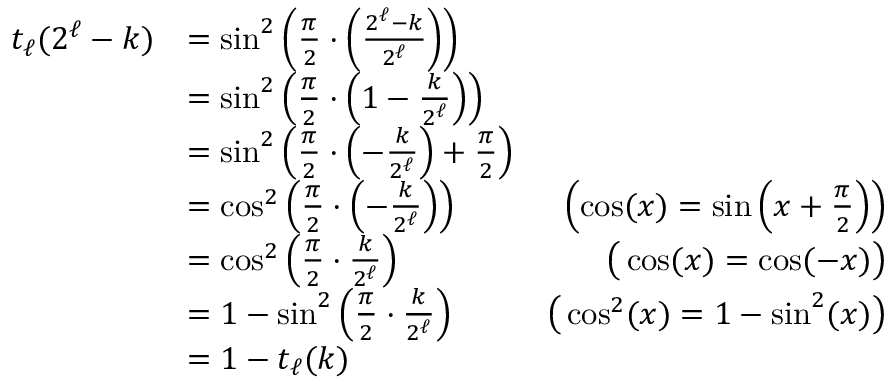<formula> <loc_0><loc_0><loc_500><loc_500>\begin{array} { r l r } { t _ { \ell } ( 2 ^ { \ell } - k ) } & { = \sin ^ { 2 } \left ( \frac { \pi } { 2 } \cdot \left ( \frac { 2 ^ { \ell } - k } { 2 ^ { \ell } } \right ) \right ) } \\ & { = \sin ^ { 2 } \left ( \frac { \pi } { 2 } \cdot \left ( 1 - \frac { k } { 2 ^ { \ell } } \right ) \right ) } \\ & { = \sin ^ { 2 } \left ( \frac { \pi } { 2 } \cdot \left ( - \frac { k } { 2 ^ { \ell } } \right ) + \frac { \pi } { 2 } \right ) } \\ & { = \cos ^ { 2 } \left ( \frac { \pi } { 2 } \cdot \left ( - \frac { k } { 2 ^ { \ell } } \right ) \right ) } & { \left ( \cos ( x ) = \sin \left ( x + \frac { \pi } { 2 } \right ) \right ) } \\ & { = \cos ^ { 2 } \left ( \frac { \pi } { 2 } \cdot \frac { k } { 2 ^ { \ell } } \right ) } & { \left ( \cos ( x ) = \cos ( - x ) \right ) } \\ & { = 1 - \sin ^ { 2 } \left ( \frac { \pi } { 2 } \cdot \frac { k } { 2 ^ { \ell } } \right ) } & { \left ( \cos ^ { 2 } ( x ) = 1 - \sin ^ { 2 } ( x ) \right ) } \\ & { = 1 - t _ { \ell } ( k ) } \end{array}</formula> 